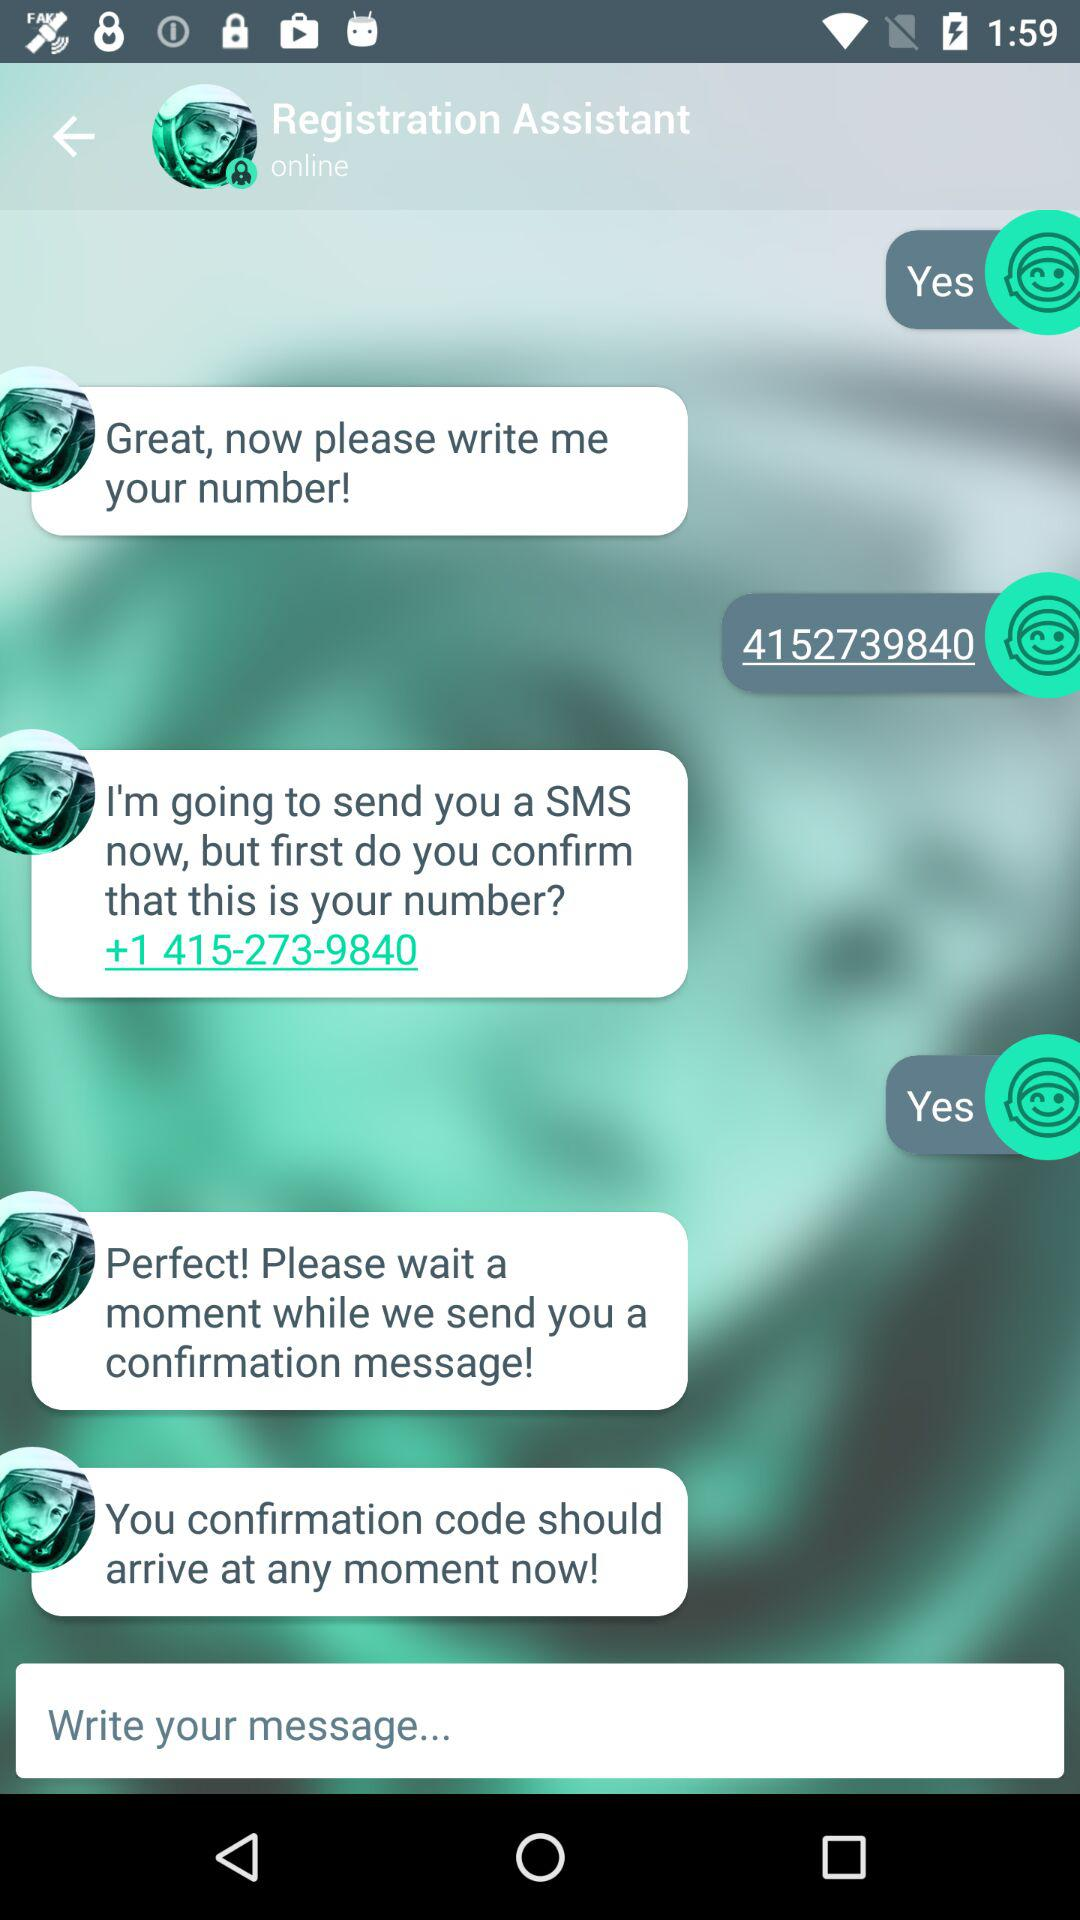What is the number given on the screen? The given number is +1 415-273-9840. 